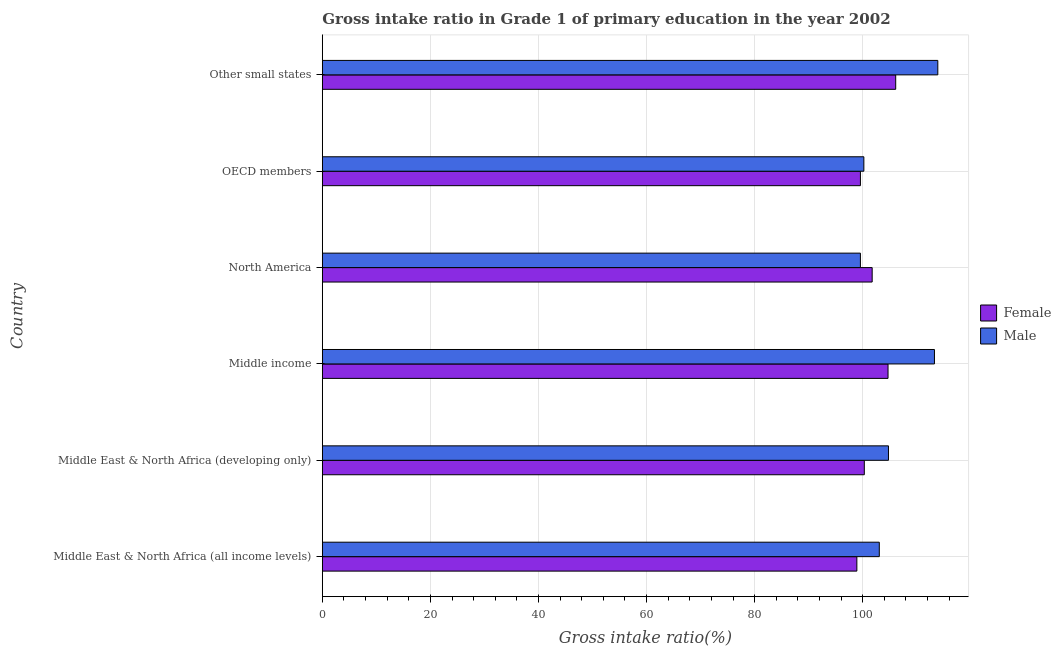How many different coloured bars are there?
Ensure brevity in your answer.  2. Are the number of bars on each tick of the Y-axis equal?
Offer a terse response. Yes. What is the label of the 2nd group of bars from the top?
Give a very brief answer. OECD members. What is the gross intake ratio(male) in Other small states?
Provide a short and direct response. 113.9. Across all countries, what is the maximum gross intake ratio(male)?
Make the answer very short. 113.9. Across all countries, what is the minimum gross intake ratio(female)?
Offer a terse response. 98.91. In which country was the gross intake ratio(female) maximum?
Your answer should be compact. Other small states. In which country was the gross intake ratio(female) minimum?
Your response must be concise. Middle East & North Africa (all income levels). What is the total gross intake ratio(male) in the graph?
Give a very brief answer. 634.78. What is the difference between the gross intake ratio(male) in Middle East & North Africa (all income levels) and that in Middle East & North Africa (developing only)?
Offer a very short reply. -1.7. What is the difference between the gross intake ratio(female) in OECD members and the gross intake ratio(male) in Middle East & North Africa (all income levels)?
Your response must be concise. -3.49. What is the average gross intake ratio(female) per country?
Keep it short and to the point. 101.89. What is the difference between the gross intake ratio(male) and gross intake ratio(female) in Other small states?
Your answer should be compact. 7.79. Is the difference between the gross intake ratio(female) in Middle East & North Africa (developing only) and OECD members greater than the difference between the gross intake ratio(male) in Middle East & North Africa (developing only) and OECD members?
Offer a terse response. No. What is the difference between the highest and the second highest gross intake ratio(male)?
Keep it short and to the point. 0.62. What is the difference between the highest and the lowest gross intake ratio(male)?
Offer a very short reply. 14.32. Is the sum of the gross intake ratio(female) in Middle East & North Africa (all income levels) and Middle income greater than the maximum gross intake ratio(male) across all countries?
Your answer should be compact. Yes. Are all the bars in the graph horizontal?
Keep it short and to the point. Yes. Does the graph contain any zero values?
Keep it short and to the point. No. Where does the legend appear in the graph?
Give a very brief answer. Center right. How many legend labels are there?
Give a very brief answer. 2. What is the title of the graph?
Give a very brief answer. Gross intake ratio in Grade 1 of primary education in the year 2002. What is the label or title of the X-axis?
Offer a terse response. Gross intake ratio(%). What is the label or title of the Y-axis?
Ensure brevity in your answer.  Country. What is the Gross intake ratio(%) in Female in Middle East & North Africa (all income levels)?
Keep it short and to the point. 98.91. What is the Gross intake ratio(%) in Male in Middle East & North Africa (all income levels)?
Ensure brevity in your answer.  103.07. What is the Gross intake ratio(%) of Female in Middle East & North Africa (developing only)?
Make the answer very short. 100.29. What is the Gross intake ratio(%) of Male in Middle East & North Africa (developing only)?
Offer a very short reply. 104.76. What is the Gross intake ratio(%) of Female in Middle income?
Make the answer very short. 104.68. What is the Gross intake ratio(%) of Male in Middle income?
Ensure brevity in your answer.  113.27. What is the Gross intake ratio(%) in Female in North America?
Offer a very short reply. 101.75. What is the Gross intake ratio(%) in Male in North America?
Your response must be concise. 99.57. What is the Gross intake ratio(%) in Female in OECD members?
Your answer should be very brief. 99.57. What is the Gross intake ratio(%) of Male in OECD members?
Offer a very short reply. 100.21. What is the Gross intake ratio(%) in Female in Other small states?
Your response must be concise. 106.1. What is the Gross intake ratio(%) of Male in Other small states?
Your answer should be very brief. 113.9. Across all countries, what is the maximum Gross intake ratio(%) of Female?
Your answer should be compact. 106.1. Across all countries, what is the maximum Gross intake ratio(%) of Male?
Make the answer very short. 113.9. Across all countries, what is the minimum Gross intake ratio(%) in Female?
Your answer should be very brief. 98.91. Across all countries, what is the minimum Gross intake ratio(%) of Male?
Provide a short and direct response. 99.57. What is the total Gross intake ratio(%) of Female in the graph?
Provide a succinct answer. 611.31. What is the total Gross intake ratio(%) in Male in the graph?
Keep it short and to the point. 634.78. What is the difference between the Gross intake ratio(%) in Female in Middle East & North Africa (all income levels) and that in Middle East & North Africa (developing only)?
Keep it short and to the point. -1.38. What is the difference between the Gross intake ratio(%) in Male in Middle East & North Africa (all income levels) and that in Middle East & North Africa (developing only)?
Your answer should be compact. -1.7. What is the difference between the Gross intake ratio(%) in Female in Middle East & North Africa (all income levels) and that in Middle income?
Make the answer very short. -5.77. What is the difference between the Gross intake ratio(%) of Male in Middle East & North Africa (all income levels) and that in Middle income?
Provide a short and direct response. -10.21. What is the difference between the Gross intake ratio(%) of Female in Middle East & North Africa (all income levels) and that in North America?
Offer a terse response. -2.83. What is the difference between the Gross intake ratio(%) in Male in Middle East & North Africa (all income levels) and that in North America?
Make the answer very short. 3.5. What is the difference between the Gross intake ratio(%) of Female in Middle East & North Africa (all income levels) and that in OECD members?
Your response must be concise. -0.66. What is the difference between the Gross intake ratio(%) of Male in Middle East & North Africa (all income levels) and that in OECD members?
Your response must be concise. 2.86. What is the difference between the Gross intake ratio(%) of Female in Middle East & North Africa (all income levels) and that in Other small states?
Keep it short and to the point. -7.19. What is the difference between the Gross intake ratio(%) in Male in Middle East & North Africa (all income levels) and that in Other small states?
Provide a succinct answer. -10.83. What is the difference between the Gross intake ratio(%) in Female in Middle East & North Africa (developing only) and that in Middle income?
Your response must be concise. -4.39. What is the difference between the Gross intake ratio(%) in Male in Middle East & North Africa (developing only) and that in Middle income?
Your answer should be compact. -8.51. What is the difference between the Gross intake ratio(%) in Female in Middle East & North Africa (developing only) and that in North America?
Give a very brief answer. -1.45. What is the difference between the Gross intake ratio(%) in Male in Middle East & North Africa (developing only) and that in North America?
Your response must be concise. 5.19. What is the difference between the Gross intake ratio(%) of Female in Middle East & North Africa (developing only) and that in OECD members?
Make the answer very short. 0.72. What is the difference between the Gross intake ratio(%) of Male in Middle East & North Africa (developing only) and that in OECD members?
Ensure brevity in your answer.  4.55. What is the difference between the Gross intake ratio(%) of Female in Middle East & North Africa (developing only) and that in Other small states?
Keep it short and to the point. -5.81. What is the difference between the Gross intake ratio(%) of Male in Middle East & North Africa (developing only) and that in Other small states?
Keep it short and to the point. -9.13. What is the difference between the Gross intake ratio(%) in Female in Middle income and that in North America?
Give a very brief answer. 2.93. What is the difference between the Gross intake ratio(%) of Male in Middle income and that in North America?
Give a very brief answer. 13.7. What is the difference between the Gross intake ratio(%) of Female in Middle income and that in OECD members?
Provide a short and direct response. 5.11. What is the difference between the Gross intake ratio(%) in Male in Middle income and that in OECD members?
Make the answer very short. 13.06. What is the difference between the Gross intake ratio(%) in Female in Middle income and that in Other small states?
Offer a terse response. -1.42. What is the difference between the Gross intake ratio(%) of Male in Middle income and that in Other small states?
Keep it short and to the point. -0.62. What is the difference between the Gross intake ratio(%) of Female in North America and that in OECD members?
Your answer should be very brief. 2.17. What is the difference between the Gross intake ratio(%) in Male in North America and that in OECD members?
Provide a succinct answer. -0.64. What is the difference between the Gross intake ratio(%) of Female in North America and that in Other small states?
Offer a terse response. -4.35. What is the difference between the Gross intake ratio(%) of Male in North America and that in Other small states?
Your answer should be compact. -14.32. What is the difference between the Gross intake ratio(%) of Female in OECD members and that in Other small states?
Your response must be concise. -6.53. What is the difference between the Gross intake ratio(%) in Male in OECD members and that in Other small states?
Offer a terse response. -13.68. What is the difference between the Gross intake ratio(%) of Female in Middle East & North Africa (all income levels) and the Gross intake ratio(%) of Male in Middle East & North Africa (developing only)?
Offer a terse response. -5.85. What is the difference between the Gross intake ratio(%) in Female in Middle East & North Africa (all income levels) and the Gross intake ratio(%) in Male in Middle income?
Offer a very short reply. -14.36. What is the difference between the Gross intake ratio(%) of Female in Middle East & North Africa (all income levels) and the Gross intake ratio(%) of Male in North America?
Offer a terse response. -0.66. What is the difference between the Gross intake ratio(%) in Female in Middle East & North Africa (all income levels) and the Gross intake ratio(%) in Male in OECD members?
Offer a very short reply. -1.3. What is the difference between the Gross intake ratio(%) of Female in Middle East & North Africa (all income levels) and the Gross intake ratio(%) of Male in Other small states?
Make the answer very short. -14.98. What is the difference between the Gross intake ratio(%) of Female in Middle East & North Africa (developing only) and the Gross intake ratio(%) of Male in Middle income?
Your response must be concise. -12.98. What is the difference between the Gross intake ratio(%) of Female in Middle East & North Africa (developing only) and the Gross intake ratio(%) of Male in North America?
Ensure brevity in your answer.  0.72. What is the difference between the Gross intake ratio(%) in Female in Middle East & North Africa (developing only) and the Gross intake ratio(%) in Male in OECD members?
Your response must be concise. 0.08. What is the difference between the Gross intake ratio(%) in Female in Middle East & North Africa (developing only) and the Gross intake ratio(%) in Male in Other small states?
Offer a terse response. -13.6. What is the difference between the Gross intake ratio(%) of Female in Middle income and the Gross intake ratio(%) of Male in North America?
Your answer should be compact. 5.11. What is the difference between the Gross intake ratio(%) in Female in Middle income and the Gross intake ratio(%) in Male in OECD members?
Keep it short and to the point. 4.47. What is the difference between the Gross intake ratio(%) of Female in Middle income and the Gross intake ratio(%) of Male in Other small states?
Provide a succinct answer. -9.21. What is the difference between the Gross intake ratio(%) of Female in North America and the Gross intake ratio(%) of Male in OECD members?
Your answer should be compact. 1.54. What is the difference between the Gross intake ratio(%) of Female in North America and the Gross intake ratio(%) of Male in Other small states?
Your response must be concise. -12.15. What is the difference between the Gross intake ratio(%) in Female in OECD members and the Gross intake ratio(%) in Male in Other small states?
Offer a very short reply. -14.32. What is the average Gross intake ratio(%) of Female per country?
Make the answer very short. 101.89. What is the average Gross intake ratio(%) in Male per country?
Provide a short and direct response. 105.8. What is the difference between the Gross intake ratio(%) in Female and Gross intake ratio(%) in Male in Middle East & North Africa (all income levels)?
Provide a short and direct response. -4.15. What is the difference between the Gross intake ratio(%) of Female and Gross intake ratio(%) of Male in Middle East & North Africa (developing only)?
Keep it short and to the point. -4.47. What is the difference between the Gross intake ratio(%) of Female and Gross intake ratio(%) of Male in Middle income?
Your answer should be very brief. -8.59. What is the difference between the Gross intake ratio(%) in Female and Gross intake ratio(%) in Male in North America?
Provide a succinct answer. 2.18. What is the difference between the Gross intake ratio(%) in Female and Gross intake ratio(%) in Male in OECD members?
Offer a terse response. -0.64. What is the difference between the Gross intake ratio(%) in Female and Gross intake ratio(%) in Male in Other small states?
Your response must be concise. -7.79. What is the ratio of the Gross intake ratio(%) of Female in Middle East & North Africa (all income levels) to that in Middle East & North Africa (developing only)?
Keep it short and to the point. 0.99. What is the ratio of the Gross intake ratio(%) of Male in Middle East & North Africa (all income levels) to that in Middle East & North Africa (developing only)?
Give a very brief answer. 0.98. What is the ratio of the Gross intake ratio(%) of Female in Middle East & North Africa (all income levels) to that in Middle income?
Your answer should be very brief. 0.94. What is the ratio of the Gross intake ratio(%) of Male in Middle East & North Africa (all income levels) to that in Middle income?
Provide a short and direct response. 0.91. What is the ratio of the Gross intake ratio(%) of Female in Middle East & North Africa (all income levels) to that in North America?
Your answer should be compact. 0.97. What is the ratio of the Gross intake ratio(%) of Male in Middle East & North Africa (all income levels) to that in North America?
Your answer should be compact. 1.04. What is the ratio of the Gross intake ratio(%) of Female in Middle East & North Africa (all income levels) to that in OECD members?
Keep it short and to the point. 0.99. What is the ratio of the Gross intake ratio(%) in Male in Middle East & North Africa (all income levels) to that in OECD members?
Offer a very short reply. 1.03. What is the ratio of the Gross intake ratio(%) in Female in Middle East & North Africa (all income levels) to that in Other small states?
Your answer should be very brief. 0.93. What is the ratio of the Gross intake ratio(%) of Male in Middle East & North Africa (all income levels) to that in Other small states?
Provide a short and direct response. 0.9. What is the ratio of the Gross intake ratio(%) in Female in Middle East & North Africa (developing only) to that in Middle income?
Make the answer very short. 0.96. What is the ratio of the Gross intake ratio(%) in Male in Middle East & North Africa (developing only) to that in Middle income?
Your answer should be compact. 0.92. What is the ratio of the Gross intake ratio(%) of Female in Middle East & North Africa (developing only) to that in North America?
Keep it short and to the point. 0.99. What is the ratio of the Gross intake ratio(%) in Male in Middle East & North Africa (developing only) to that in North America?
Give a very brief answer. 1.05. What is the ratio of the Gross intake ratio(%) in Female in Middle East & North Africa (developing only) to that in OECD members?
Provide a short and direct response. 1.01. What is the ratio of the Gross intake ratio(%) in Male in Middle East & North Africa (developing only) to that in OECD members?
Give a very brief answer. 1.05. What is the ratio of the Gross intake ratio(%) in Female in Middle East & North Africa (developing only) to that in Other small states?
Provide a short and direct response. 0.95. What is the ratio of the Gross intake ratio(%) in Male in Middle East & North Africa (developing only) to that in Other small states?
Your answer should be compact. 0.92. What is the ratio of the Gross intake ratio(%) of Female in Middle income to that in North America?
Provide a short and direct response. 1.03. What is the ratio of the Gross intake ratio(%) of Male in Middle income to that in North America?
Your answer should be very brief. 1.14. What is the ratio of the Gross intake ratio(%) in Female in Middle income to that in OECD members?
Provide a succinct answer. 1.05. What is the ratio of the Gross intake ratio(%) in Male in Middle income to that in OECD members?
Your response must be concise. 1.13. What is the ratio of the Gross intake ratio(%) in Female in Middle income to that in Other small states?
Offer a very short reply. 0.99. What is the ratio of the Gross intake ratio(%) in Female in North America to that in OECD members?
Provide a short and direct response. 1.02. What is the ratio of the Gross intake ratio(%) in Male in North America to that in OECD members?
Your response must be concise. 0.99. What is the ratio of the Gross intake ratio(%) in Female in North America to that in Other small states?
Your answer should be compact. 0.96. What is the ratio of the Gross intake ratio(%) of Male in North America to that in Other small states?
Offer a very short reply. 0.87. What is the ratio of the Gross intake ratio(%) in Female in OECD members to that in Other small states?
Ensure brevity in your answer.  0.94. What is the ratio of the Gross intake ratio(%) in Male in OECD members to that in Other small states?
Your answer should be very brief. 0.88. What is the difference between the highest and the second highest Gross intake ratio(%) of Female?
Give a very brief answer. 1.42. What is the difference between the highest and the second highest Gross intake ratio(%) in Male?
Offer a terse response. 0.62. What is the difference between the highest and the lowest Gross intake ratio(%) of Female?
Ensure brevity in your answer.  7.19. What is the difference between the highest and the lowest Gross intake ratio(%) in Male?
Provide a short and direct response. 14.32. 